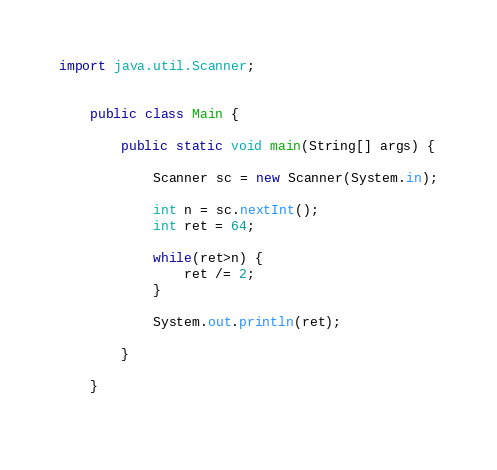Convert code to text. <code><loc_0><loc_0><loc_500><loc_500><_Java_>import java.util.Scanner;


	public class Main {
		
		public static void main(String[] args) {

			Scanner sc = new Scanner(System.in);
			
			int n = sc.nextInt();
			int ret = 64;
			
			while(ret>n) {
				ret /= 2;
			}
			
			System.out.println(ret);
			
	    }
		
	}
	
</code> 